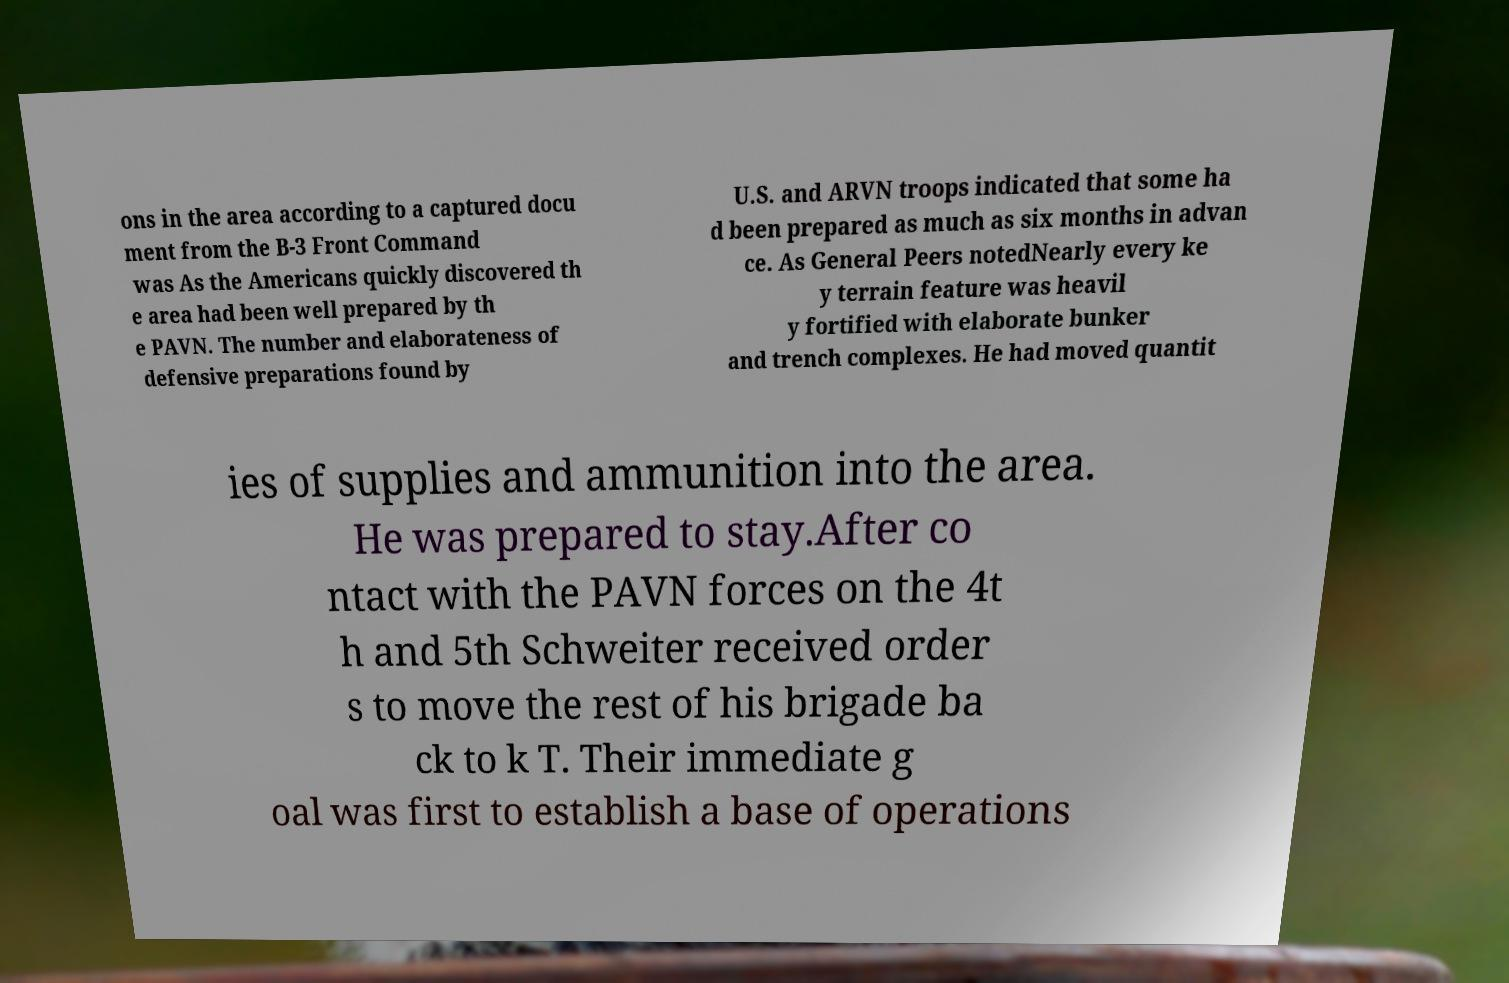There's text embedded in this image that I need extracted. Can you transcribe it verbatim? ons in the area according to a captured docu ment from the B-3 Front Command was As the Americans quickly discovered th e area had been well prepared by th e PAVN. The number and elaborateness of defensive preparations found by U.S. and ARVN troops indicated that some ha d been prepared as much as six months in advan ce. As General Peers notedNearly every ke y terrain feature was heavil y fortified with elaborate bunker and trench complexes. He had moved quantit ies of supplies and ammunition into the area. He was prepared to stay.After co ntact with the PAVN forces on the 4t h and 5th Schweiter received order s to move the rest of his brigade ba ck to k T. Their immediate g oal was first to establish a base of operations 